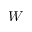Convert formula to latex. <formula><loc_0><loc_0><loc_500><loc_500>W</formula> 